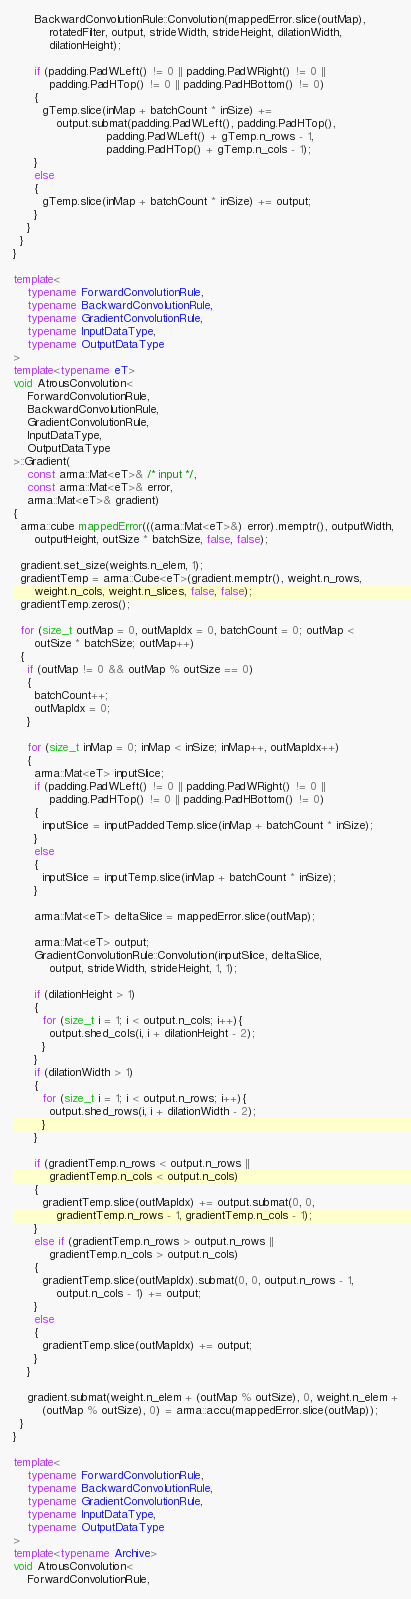Convert code to text. <code><loc_0><loc_0><loc_500><loc_500><_C++_>      BackwardConvolutionRule::Convolution(mappedError.slice(outMap),
          rotatedFilter, output, strideWidth, strideHeight, dilationWidth,
          dilationHeight);

      if (padding.PadWLeft() != 0 || padding.PadWRight() != 0 ||
          padding.PadHTop() != 0 || padding.PadHBottom() != 0)
      {
        gTemp.slice(inMap + batchCount * inSize) +=
            output.submat(padding.PadWLeft(), padding.PadHTop(),
                          padding.PadWLeft() + gTemp.n_rows - 1,
                          padding.PadHTop() + gTemp.n_cols - 1);
      }
      else
      {
        gTemp.slice(inMap + batchCount * inSize) += output;
      }
    }
  }
}

template<
    typename ForwardConvolutionRule,
    typename BackwardConvolutionRule,
    typename GradientConvolutionRule,
    typename InputDataType,
    typename OutputDataType
>
template<typename eT>
void AtrousConvolution<
    ForwardConvolutionRule,
    BackwardConvolutionRule,
    GradientConvolutionRule,
    InputDataType,
    OutputDataType
>::Gradient(
    const arma::Mat<eT>& /* input */,
    const arma::Mat<eT>& error,
    arma::Mat<eT>& gradient)
{
  arma::cube mappedError(((arma::Mat<eT>&) error).memptr(), outputWidth,
      outputHeight, outSize * batchSize, false, false);

  gradient.set_size(weights.n_elem, 1);
  gradientTemp = arma::Cube<eT>(gradient.memptr(), weight.n_rows,
      weight.n_cols, weight.n_slices, false, false);
  gradientTemp.zeros();

  for (size_t outMap = 0, outMapIdx = 0, batchCount = 0; outMap <
      outSize * batchSize; outMap++)
  {
    if (outMap != 0 && outMap % outSize == 0)
    {
      batchCount++;
      outMapIdx = 0;
    }

    for (size_t inMap = 0; inMap < inSize; inMap++, outMapIdx++)
    {
      arma::Mat<eT> inputSlice;
      if (padding.PadWLeft() != 0 || padding.PadWRight() != 0 ||
          padding.PadHTop() != 0 || padding.PadHBottom() != 0)
      {
        inputSlice = inputPaddedTemp.slice(inMap + batchCount * inSize);
      }
      else
      {
        inputSlice = inputTemp.slice(inMap + batchCount * inSize);
      }

      arma::Mat<eT> deltaSlice = mappedError.slice(outMap);

      arma::Mat<eT> output;
      GradientConvolutionRule::Convolution(inputSlice, deltaSlice,
          output, strideWidth, strideHeight, 1, 1);

      if (dilationHeight > 1)
      {
        for (size_t i = 1; i < output.n_cols; i++){
          output.shed_cols(i, i + dilationHeight - 2);
        }
      }
      if (dilationWidth > 1)
      {
        for (size_t i = 1; i < output.n_rows; i++){
          output.shed_rows(i, i + dilationWidth - 2);
        }
      }

      if (gradientTemp.n_rows < output.n_rows ||
          gradientTemp.n_cols < output.n_cols)
      {
        gradientTemp.slice(outMapIdx) += output.submat(0, 0,
            gradientTemp.n_rows - 1, gradientTemp.n_cols - 1);
      }
      else if (gradientTemp.n_rows > output.n_rows ||
          gradientTemp.n_cols > output.n_cols)
      {
        gradientTemp.slice(outMapIdx).submat(0, 0, output.n_rows - 1,
            output.n_cols - 1) += output;
      }
      else
      {
        gradientTemp.slice(outMapIdx) += output;
      }
    }

    gradient.submat(weight.n_elem + (outMap % outSize), 0, weight.n_elem +
        (outMap % outSize), 0) = arma::accu(mappedError.slice(outMap));
  }
}

template<
    typename ForwardConvolutionRule,
    typename BackwardConvolutionRule,
    typename GradientConvolutionRule,
    typename InputDataType,
    typename OutputDataType
>
template<typename Archive>
void AtrousConvolution<
    ForwardConvolutionRule,</code> 